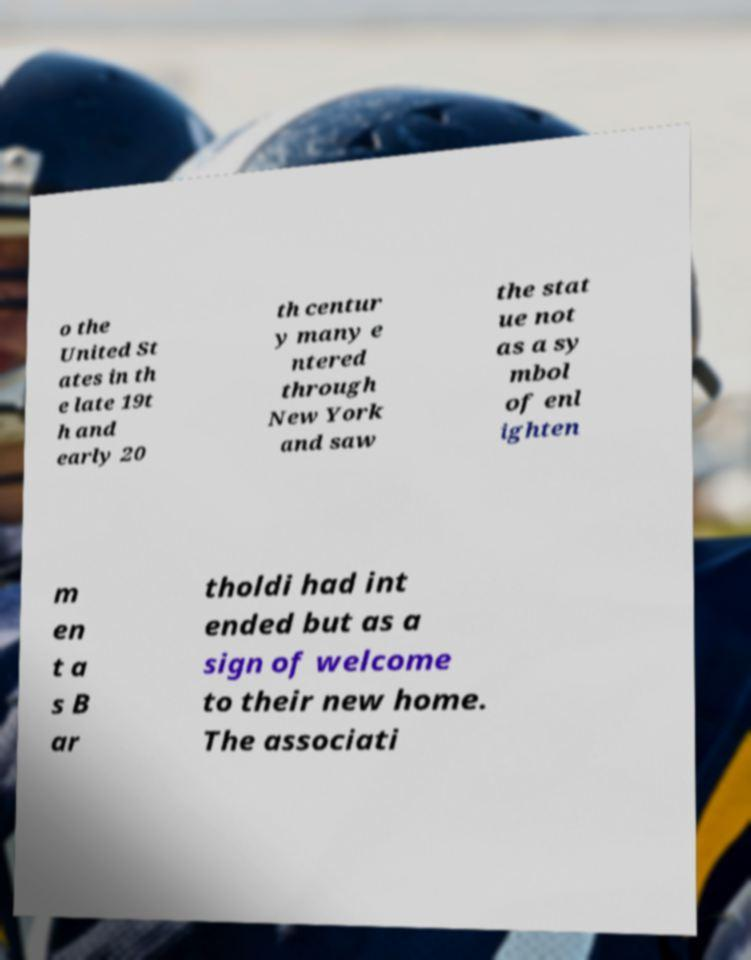Could you assist in decoding the text presented in this image and type it out clearly? o the United St ates in th e late 19t h and early 20 th centur y many e ntered through New York and saw the stat ue not as a sy mbol of enl ighten m en t a s B ar tholdi had int ended but as a sign of welcome to their new home. The associati 